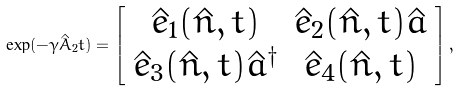<formula> <loc_0><loc_0><loc_500><loc_500>\exp ( - \gamma \hat { A } _ { 2 } t ) = \left [ \begin{array} { c c c c } \hat { e } _ { 1 } ( \hat { n } , t ) & \hat { e } _ { 2 } ( \hat { n } , t ) \hat { a } \\ \hat { e } _ { 3 } ( \hat { n } , t ) \hat { a } ^ { \dagger } & \hat { e } _ { 4 } ( \hat { n } , t ) \\ \end{array} \right ] ,</formula> 